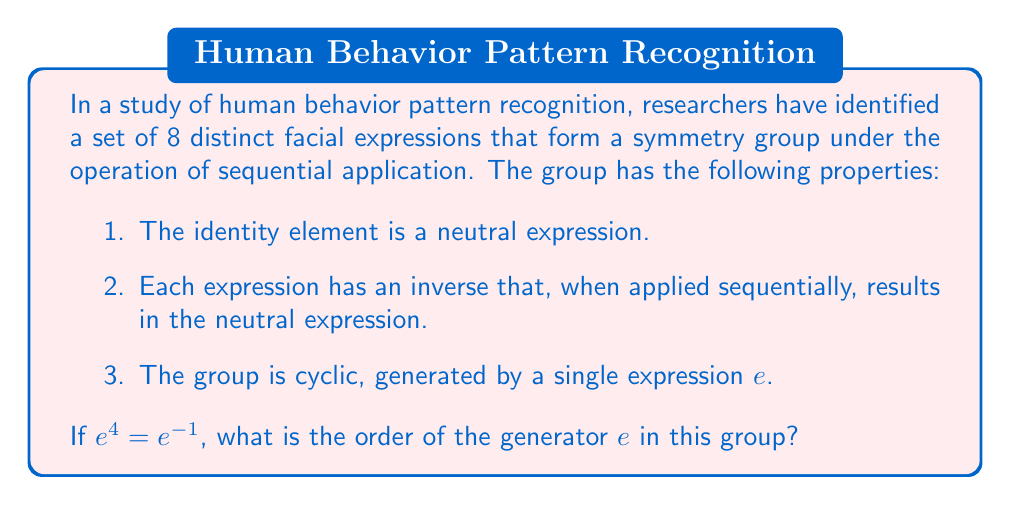Can you answer this question? Let's approach this step-by-step:

1) In a cyclic group of order 8, we can represent the elements as powers of the generator $e$:
   $\{e^0, e^1, e^2, e^3, e^4, e^5, e^6, e^7\}$

2) We're given that $e^4 = e^{-1}$. In a group of order 8, this means:
   $e^4 = e^7$ (since $e^8 = e^0 = \text{identity}$)

3) We can set up the equation:
   $e^4 = e^7$

4) In modular arithmetic modulo 8 (since the group has order 8), this is equivalent to:
   $4 \equiv 7 \pmod{8}$
   
5) To solve this, we need to find the smallest positive integer $n$ such that:
   $4n \equiv 7n \pmod{8}$

6) Rearranging:
   $3n \equiv 0 \pmod{8}$

7) The smallest positive $n$ that satisfies this is $n = 8/\gcd(3,8) = 8/1 = 8$

8) This means that $e^8 = \text{identity}$, and no smaller power of $e$ equals the identity.

Therefore, the order of the generator $e$ is 8.
Answer: 8 